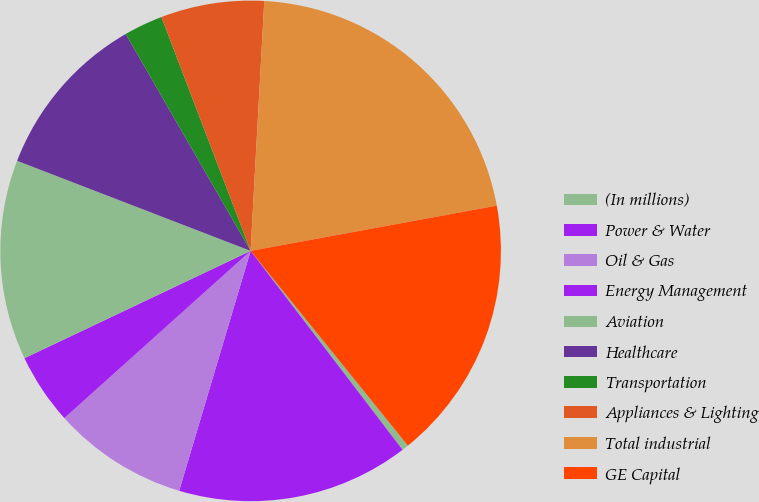Convert chart to OTSL. <chart><loc_0><loc_0><loc_500><loc_500><pie_chart><fcel>(In millions)<fcel>Power & Water<fcel>Oil & Gas<fcel>Energy Management<fcel>Aviation<fcel>Healthcare<fcel>Transportation<fcel>Appliances & Lighting<fcel>Total industrial<fcel>GE Capital<nl><fcel>0.43%<fcel>14.99%<fcel>8.75%<fcel>4.59%<fcel>12.91%<fcel>10.83%<fcel>2.51%<fcel>6.67%<fcel>21.24%<fcel>17.08%<nl></chart> 